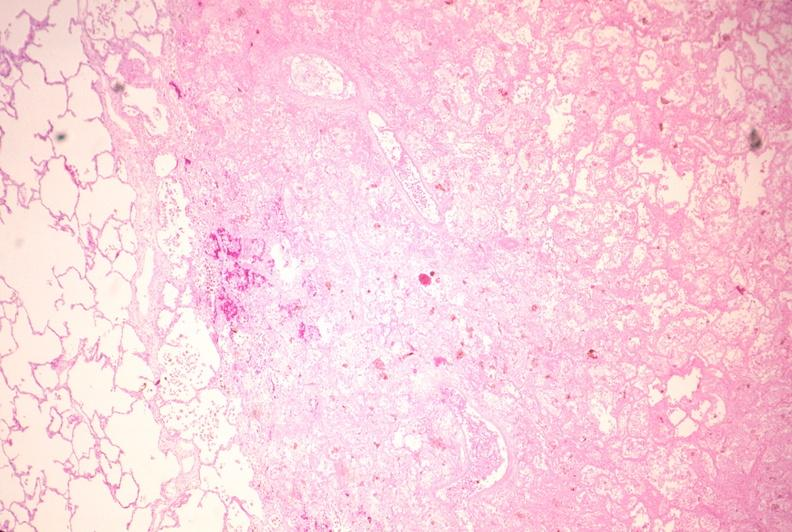what is present?
Answer the question using a single word or phrase. Respiratory 